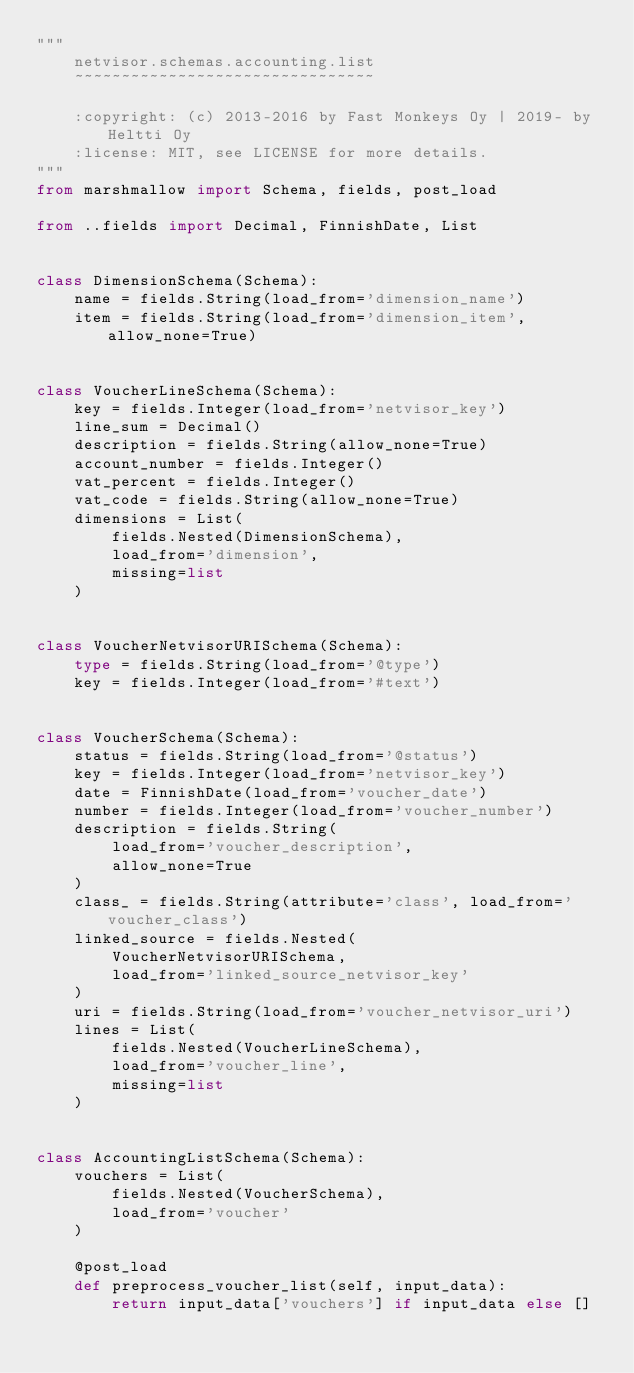<code> <loc_0><loc_0><loc_500><loc_500><_Python_>"""
    netvisor.schemas.accounting.list
    ~~~~~~~~~~~~~~~~~~~~~~~~~~~~~~~~

    :copyright: (c) 2013-2016 by Fast Monkeys Oy | 2019- by Heltti Oy
    :license: MIT, see LICENSE for more details.
"""
from marshmallow import Schema, fields, post_load

from ..fields import Decimal, FinnishDate, List


class DimensionSchema(Schema):
    name = fields.String(load_from='dimension_name')
    item = fields.String(load_from='dimension_item', allow_none=True)


class VoucherLineSchema(Schema):
    key = fields.Integer(load_from='netvisor_key')
    line_sum = Decimal()
    description = fields.String(allow_none=True)
    account_number = fields.Integer()
    vat_percent = fields.Integer()
    vat_code = fields.String(allow_none=True)
    dimensions = List(
        fields.Nested(DimensionSchema),
        load_from='dimension',
        missing=list
    )


class VoucherNetvisorURISchema(Schema):
    type = fields.String(load_from='@type')
    key = fields.Integer(load_from='#text')


class VoucherSchema(Schema):
    status = fields.String(load_from='@status')
    key = fields.Integer(load_from='netvisor_key')
    date = FinnishDate(load_from='voucher_date')
    number = fields.Integer(load_from='voucher_number')
    description = fields.String(
        load_from='voucher_description',
        allow_none=True
    )
    class_ = fields.String(attribute='class', load_from='voucher_class')
    linked_source = fields.Nested(
        VoucherNetvisorURISchema,
        load_from='linked_source_netvisor_key'
    )
    uri = fields.String(load_from='voucher_netvisor_uri')
    lines = List(
        fields.Nested(VoucherLineSchema),
        load_from='voucher_line',
        missing=list
    )


class AccountingListSchema(Schema):
    vouchers = List(
        fields.Nested(VoucherSchema),
        load_from='voucher'
    )

    @post_load
    def preprocess_voucher_list(self, input_data):
        return input_data['vouchers'] if input_data else []
</code> 